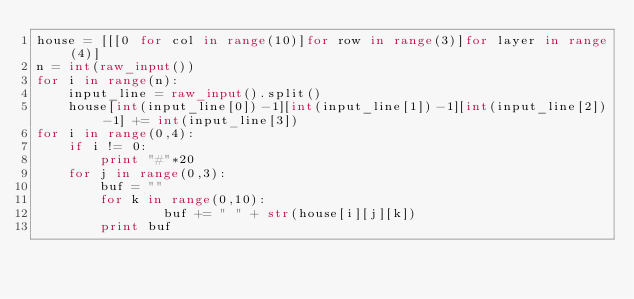<code> <loc_0><loc_0><loc_500><loc_500><_Python_>house = [[[0 for col in range(10)]for row in range(3)]for layer in range(4)]
n = int(raw_input())
for i in range(n):
    input_line = raw_input().split()
    house[int(input_line[0])-1][int(input_line[1])-1][int(input_line[2])-1] += int(input_line[3])
for i in range(0,4):
    if i != 0:
        print "#"*20
    for j in range(0,3):
        buf = ""
        for k in range(0,10):
                buf += " " + str(house[i][j][k])
        print buf</code> 